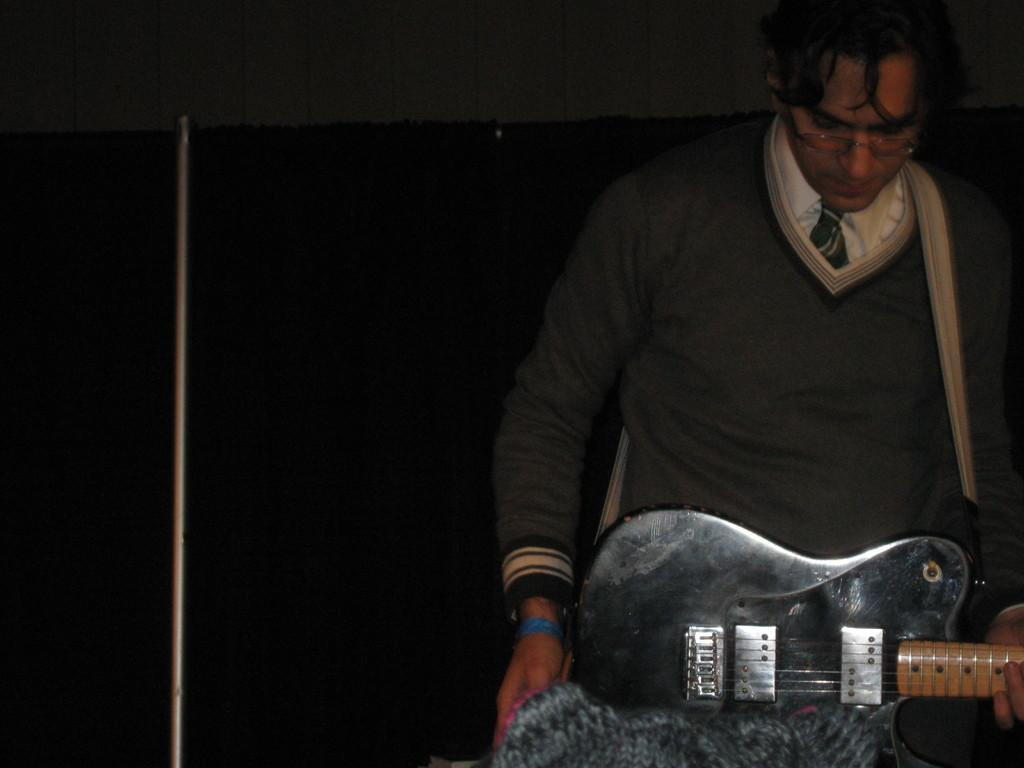Who is the main subject in the image? There is a man in the image. What is the man holding in the image? The man is holding a guitar. Can you describe the background of the image? The background of the image is dark. How many giants can be seen in the image? There are no giants present in the image. What type of fold can be seen in the man's clothing in the image? There is no fold visible in the man's clothing in the image. 